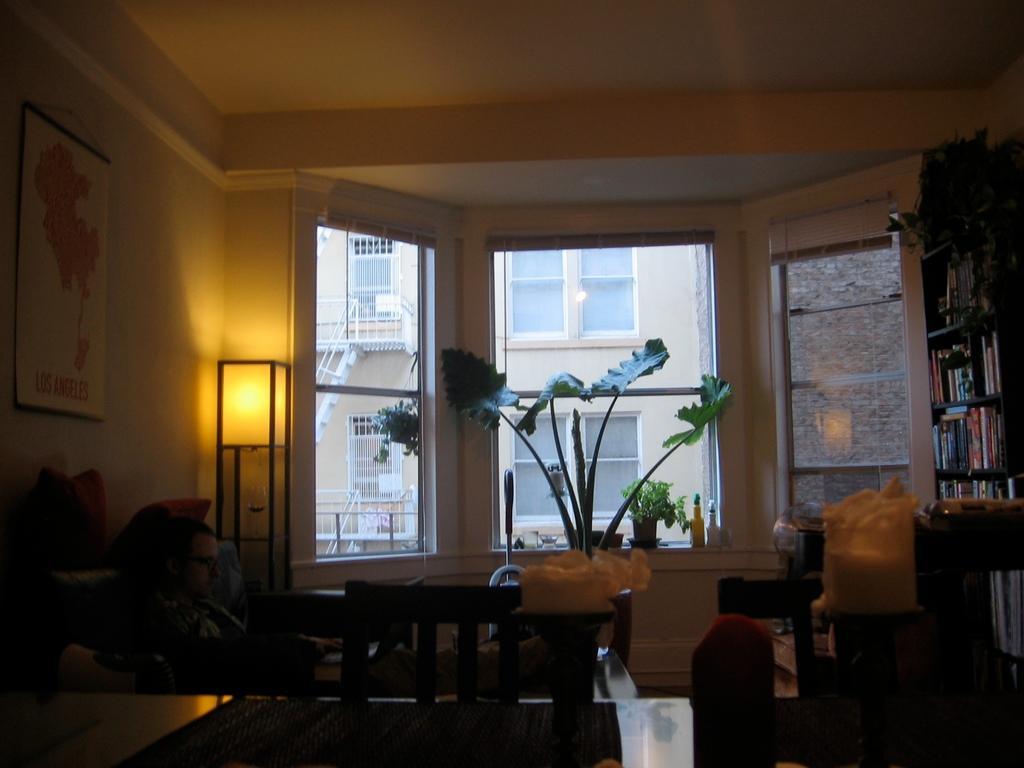Please provide a concise description of this image. In this image I can see a table and chairs. There is a plant pot. There are book shelves on the right and a lamp and a photo frame on the left. There is a window at the back. 